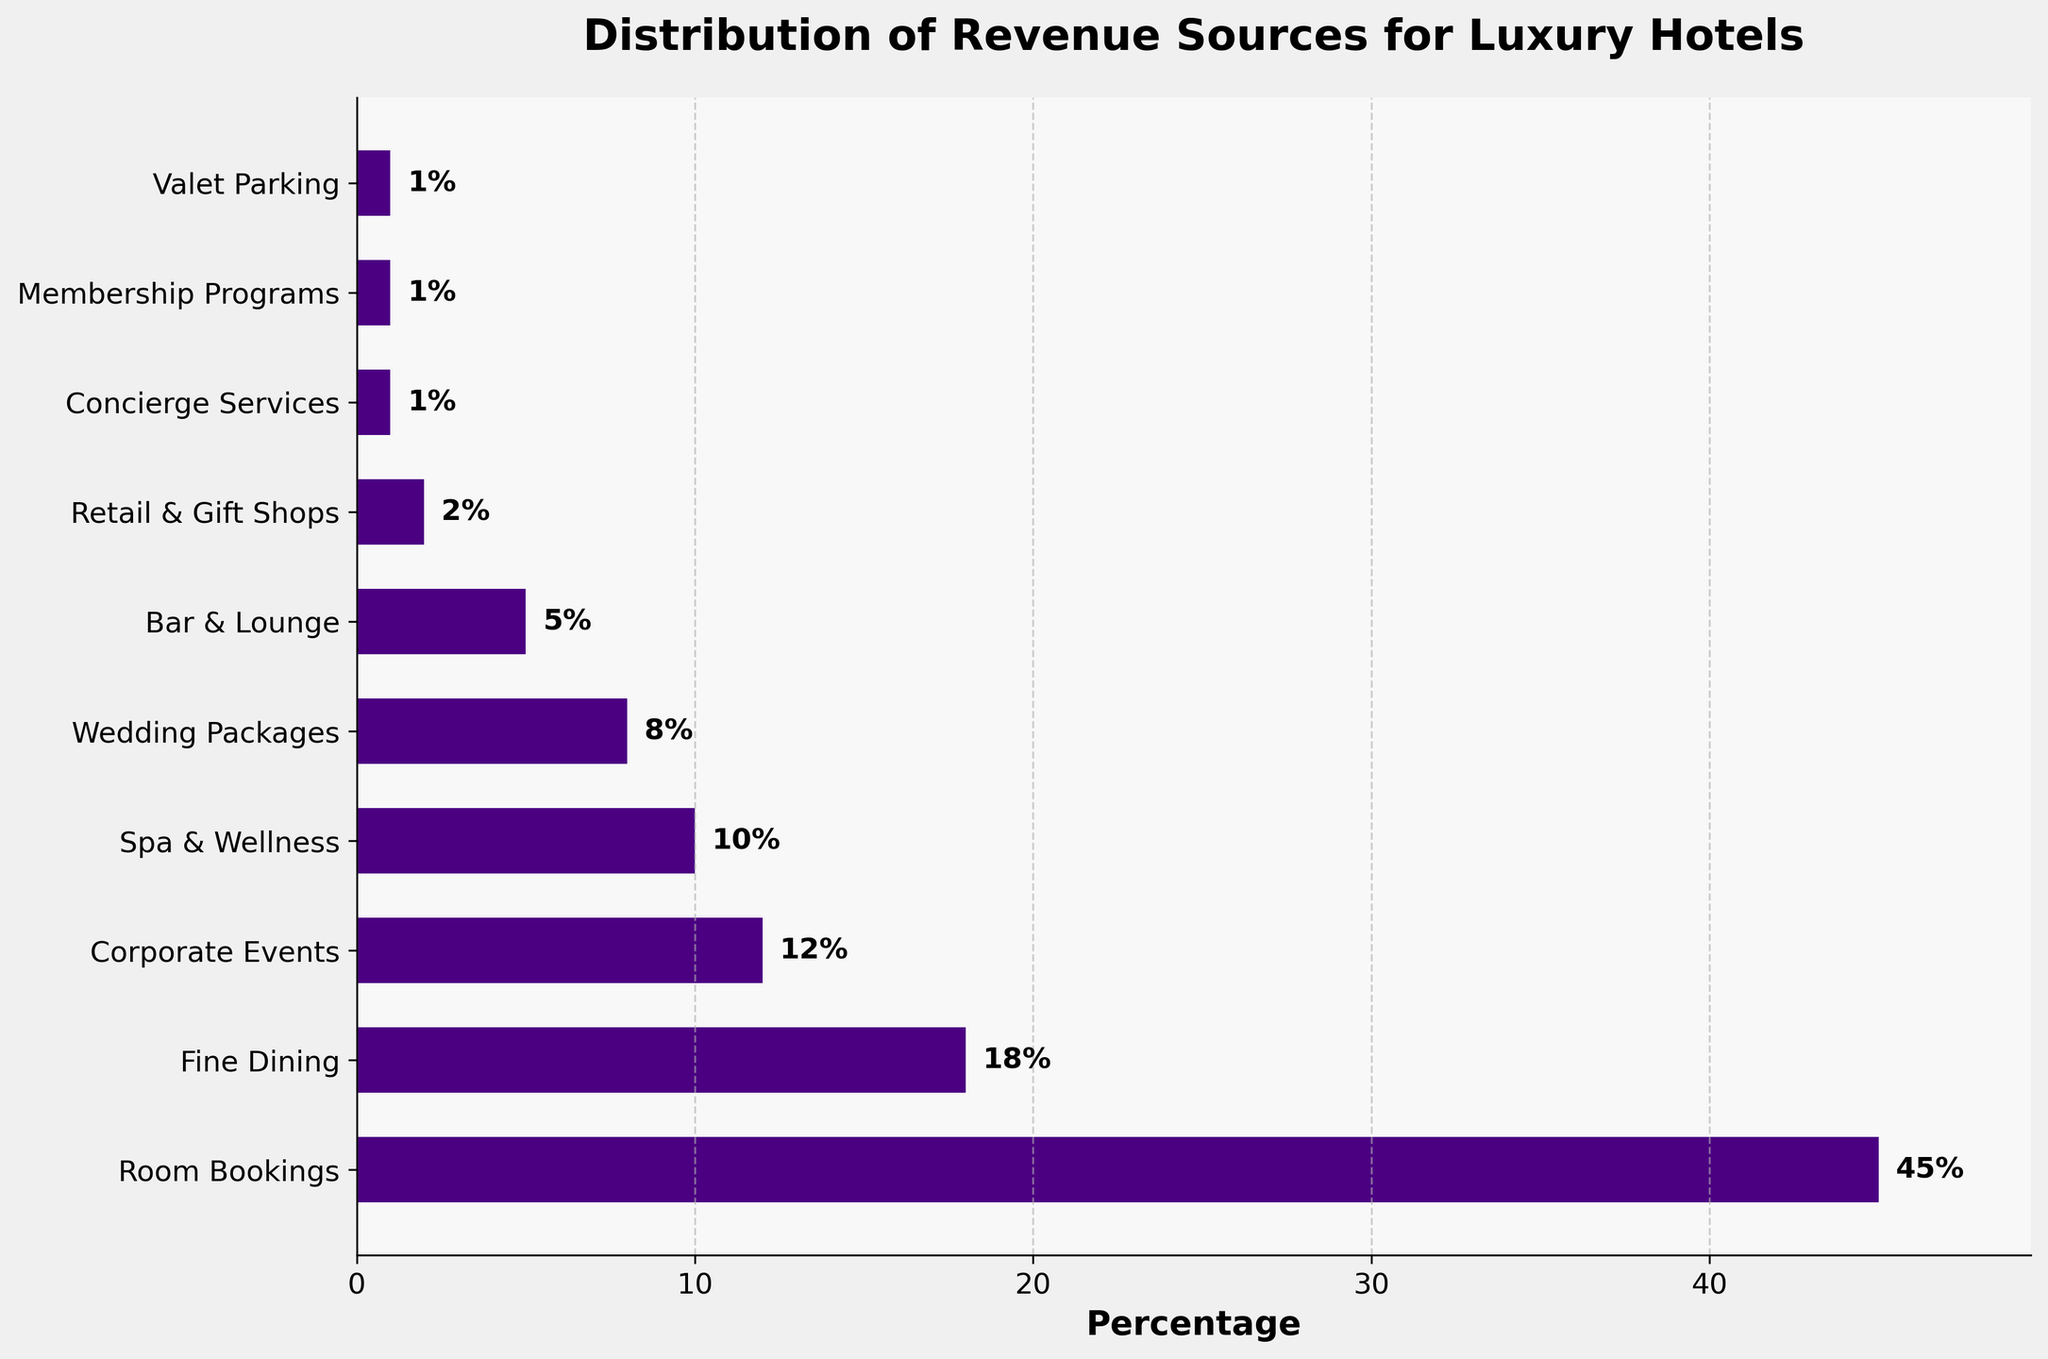Which revenue source contributes the most to the total revenue for luxury hotels? The figure shows that 'Room Bookings' has the highest percentage contribution.
Answer: Room Bookings What is the percentage contribution of Spa & Wellness to the total revenue? The figure displays a horizontal bar suggesting 'Spa & Wellness' contributes 10% to the total revenue.
Answer: 10% How much higher is the revenue from Room Bookings compared to Fine Dining? The percentage for Room Bookings is 45% and for Fine Dining is 18%. The difference is found by subtracting 18% from 45%. 45% - 18% = 27%.
Answer: 27% Which revenue source contributes the least to the total revenue? The figure indicates that 'Concierge Services,' 'Membership Programs,' and 'Valet Parking' each contribute the smallest percentage, all at 1%.
Answer: Concierge Services, Membership Programs, Valet Parking What is the total percentage contribution of Wedding Packages and Corporate Events combined? Adding up the percentages for Wedding Packages (8%) and Corporate Events (12%) results in 8% + 12% = 20%.
Answer: 20% Which two sources have a combined contribution equal to the contribution of Fine Dining? The percentage for Fine Dining is 18%. Wedding Packages (8%) and Spa & Wellness (10%) together make 8% + 10% = 18%, which equals the contribution of Fine Dining.
Answer: Wedding Packages and Spa & Wellness How does the length of the bar for Bar & Lounge compare to that of Corporate Events? The figure shows that Corporate Events contribute 12%, while Bar & Lounge contributes 5%. The bar for Corporate Events is more than twice the length of the bar for Bar & Lounge.
Answer: Corporate Events bar is more than twice as long What is the combined percentage of all revenue sources that contribute less than 5% each? Adding the percentages for Retail & Gift Shops (2%), Concierge Services (1%), Membership Programs (1%), and Valet Parking (1%) results in 2% + 1% + 1% + 1% = 5%.
Answer: 5% What is the average percentage contribution of all revenue sources in the figure? Summing up all the contributions: 45% + 18% + 12% + 10% + 8% + 5% + 2% + 1% + 1% + 1% = 103%. There are 10 revenue sources. The average is 103% / 10 = 10.3%.
Answer: 10.3% Are there any revenue sources contributing equally to the total revenue? If yes, which ones? The figure shows that 'Concierge Services,' 'Membership Programs,' and 'Valet Parking' each contribute the same percentage of 1%.
Answer: Concierge Services, Membership Programs, Valet Parking 